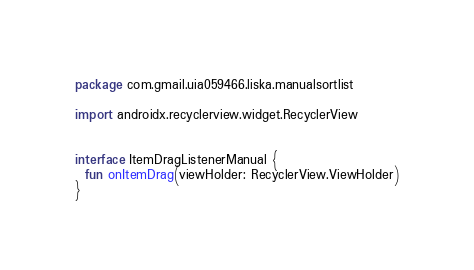<code> <loc_0><loc_0><loc_500><loc_500><_Kotlin_>package com.gmail.uia059466.liska.manualsortlist

import androidx.recyclerview.widget.RecyclerView


interface ItemDragListenerManual {
  fun onItemDrag(viewHolder: RecyclerView.ViewHolder)
}</code> 